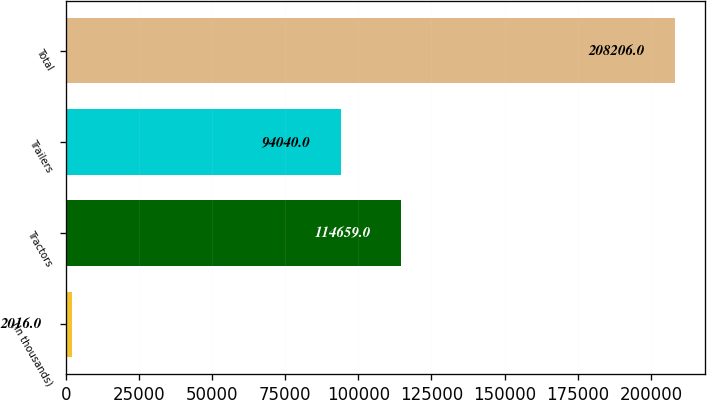Convert chart to OTSL. <chart><loc_0><loc_0><loc_500><loc_500><bar_chart><fcel>(In thousands)<fcel>Tractors<fcel>Trailers<fcel>Total<nl><fcel>2016<fcel>114659<fcel>94040<fcel>208206<nl></chart> 